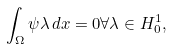<formula> <loc_0><loc_0><loc_500><loc_500>\int _ { \Omega } \psi \lambda \, d x = 0 \forall \lambda \in H ^ { 1 } _ { 0 } ,</formula> 